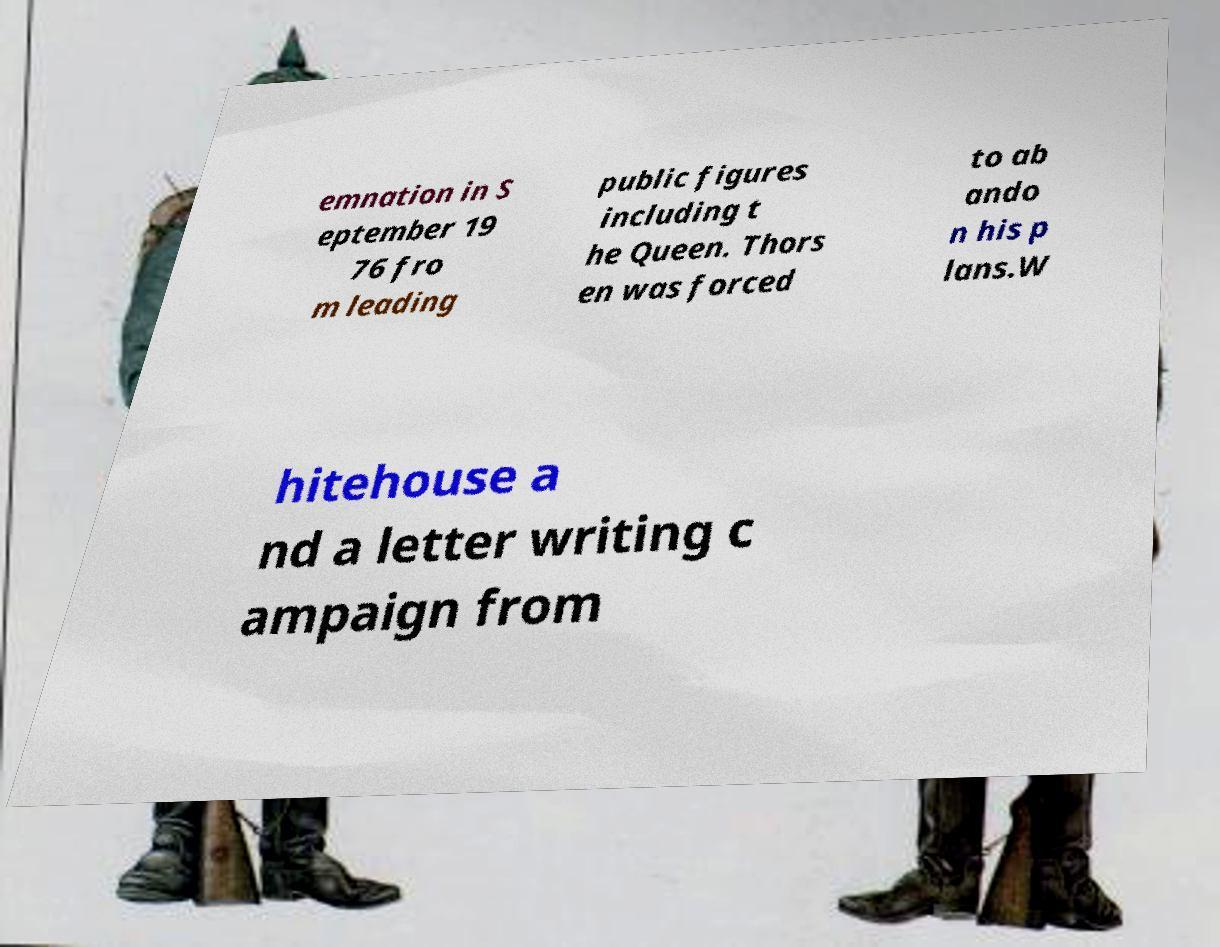I need the written content from this picture converted into text. Can you do that? emnation in S eptember 19 76 fro m leading public figures including t he Queen. Thors en was forced to ab ando n his p lans.W hitehouse a nd a letter writing c ampaign from 